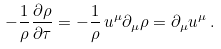Convert formula to latex. <formula><loc_0><loc_0><loc_500><loc_500>- \frac { 1 } { \rho } \frac { \partial \rho } { \partial \tau } = - \frac { 1 } { \rho } \, u ^ { \mu } \partial _ { \mu } \rho = \partial _ { \mu } u ^ { \mu } \, .</formula> 